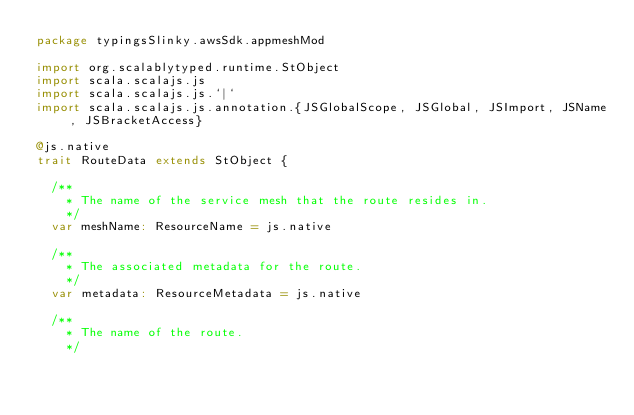Convert code to text. <code><loc_0><loc_0><loc_500><loc_500><_Scala_>package typingsSlinky.awsSdk.appmeshMod

import org.scalablytyped.runtime.StObject
import scala.scalajs.js
import scala.scalajs.js.`|`
import scala.scalajs.js.annotation.{JSGlobalScope, JSGlobal, JSImport, JSName, JSBracketAccess}

@js.native
trait RouteData extends StObject {
  
  /**
    * The name of the service mesh that the route resides in.
    */
  var meshName: ResourceName = js.native
  
  /**
    * The associated metadata for the route.
    */
  var metadata: ResourceMetadata = js.native
  
  /**
    * The name of the route.
    */</code> 